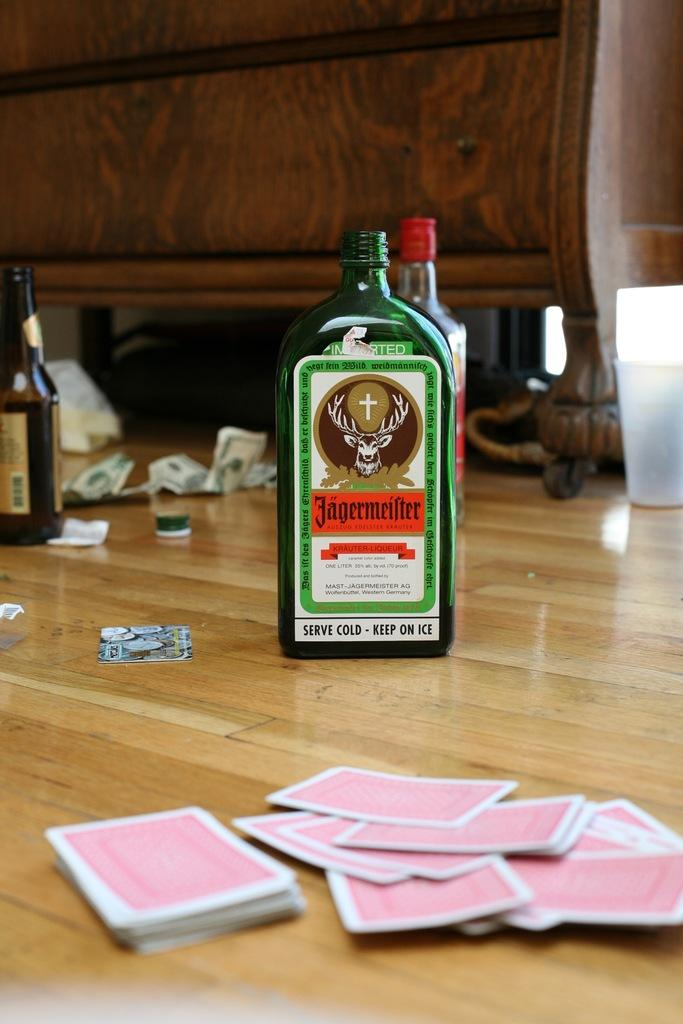What is the color of the bottle in the image? The bottle in the image is green. What is on the bottle? The bottle has a label on it. What is on the floor in the image? Playing cards are on the floor. What can be seen in the background of the image? There is money, a glass, a cupboard, and more bottles visible in the background. How many frogs are sitting on the bottle in the image? There are no frogs present in the image. What type of liquid is being poured from the pail in the image? There is no pail present in the image. 